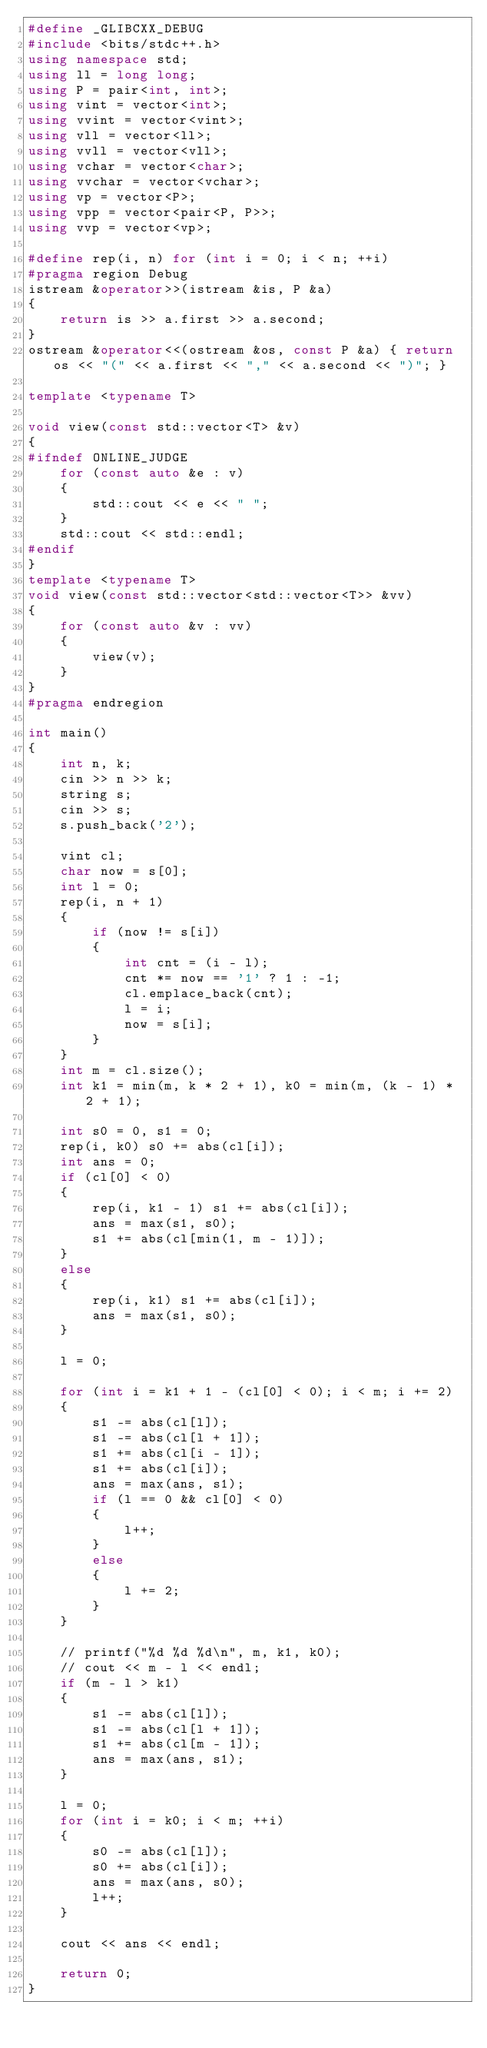<code> <loc_0><loc_0><loc_500><loc_500><_C++_>#define _GLIBCXX_DEBUG
#include <bits/stdc++.h>
using namespace std;
using ll = long long;
using P = pair<int, int>;
using vint = vector<int>;
using vvint = vector<vint>;
using vll = vector<ll>;
using vvll = vector<vll>;
using vchar = vector<char>;
using vvchar = vector<vchar>;
using vp = vector<P>;
using vpp = vector<pair<P, P>>;
using vvp = vector<vp>;

#define rep(i, n) for (int i = 0; i < n; ++i)
#pragma region Debug
istream &operator>>(istream &is, P &a)
{
    return is >> a.first >> a.second;
}
ostream &operator<<(ostream &os, const P &a) { return os << "(" << a.first << "," << a.second << ")"; }

template <typename T>

void view(const std::vector<T> &v)
{
#ifndef ONLINE_JUDGE
    for (const auto &e : v)
    {
        std::cout << e << " ";
    }
    std::cout << std::endl;
#endif
}
template <typename T>
void view(const std::vector<std::vector<T>> &vv)
{
    for (const auto &v : vv)
    {
        view(v);
    }
}
#pragma endregion

int main()
{
    int n, k;
    cin >> n >> k;
    string s;
    cin >> s;
    s.push_back('2');

    vint cl;
    char now = s[0];
    int l = 0;
    rep(i, n + 1)
    {
        if (now != s[i])
        {
            int cnt = (i - l);
            cnt *= now == '1' ? 1 : -1;
            cl.emplace_back(cnt);
            l = i;
            now = s[i];
        }
    }
    int m = cl.size();
    int k1 = min(m, k * 2 + 1), k0 = min(m, (k - 1) * 2 + 1);

    int s0 = 0, s1 = 0;
    rep(i, k0) s0 += abs(cl[i]);
    int ans = 0;
    if (cl[0] < 0)
    {
        rep(i, k1 - 1) s1 += abs(cl[i]);
        ans = max(s1, s0);
        s1 += abs(cl[min(1, m - 1)]);
    }
    else
    {
        rep(i, k1) s1 += abs(cl[i]);
        ans = max(s1, s0);
    }

    l = 0;

    for (int i = k1 + 1 - (cl[0] < 0); i < m; i += 2)
    {
        s1 -= abs(cl[l]);
        s1 -= abs(cl[l + 1]);
        s1 += abs(cl[i - 1]);
        s1 += abs(cl[i]);
        ans = max(ans, s1);
        if (l == 0 && cl[0] < 0)
        {
            l++;
        }
        else
        {
            l += 2;
        }
    }

    // printf("%d %d %d\n", m, k1, k0);
    // cout << m - l << endl;
    if (m - l > k1)
    {
        s1 -= abs(cl[l]);
        s1 -= abs(cl[l + 1]);
        s1 += abs(cl[m - 1]);
        ans = max(ans, s1);
    }

    l = 0;
    for (int i = k0; i < m; ++i)
    {
        s0 -= abs(cl[l]);
        s0 += abs(cl[i]);
        ans = max(ans, s0);
        l++;
    }

    cout << ans << endl;

    return 0;
}</code> 